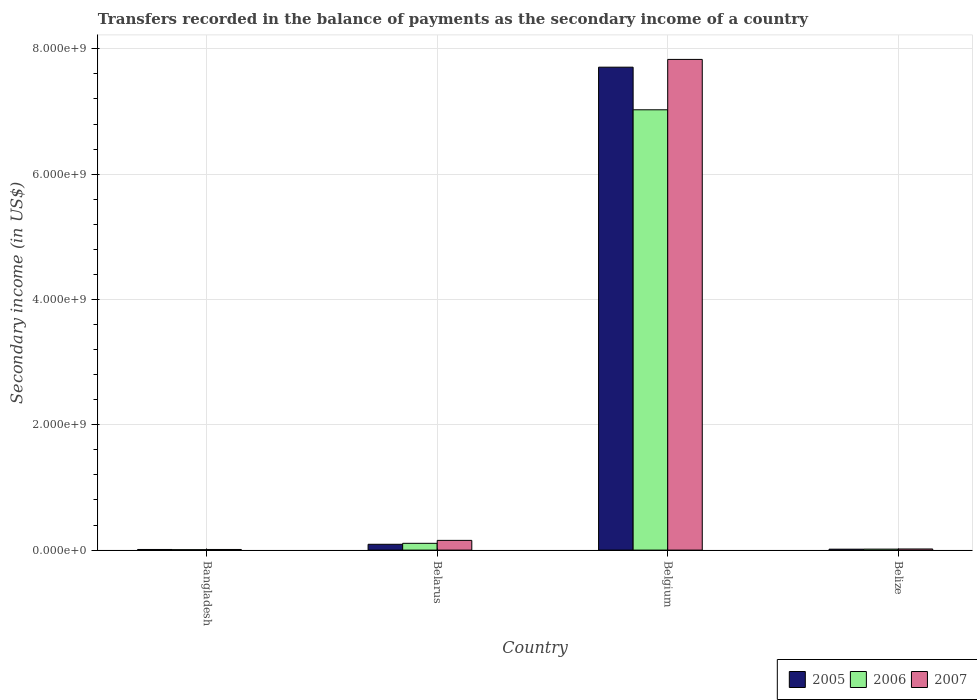How many different coloured bars are there?
Provide a succinct answer. 3. Are the number of bars on each tick of the X-axis equal?
Offer a very short reply. Yes. How many bars are there on the 4th tick from the left?
Ensure brevity in your answer.  3. What is the label of the 3rd group of bars from the left?
Ensure brevity in your answer.  Belgium. In how many cases, is the number of bars for a given country not equal to the number of legend labels?
Provide a short and direct response. 0. What is the secondary income of in 2005 in Bangladesh?
Your answer should be very brief. 9.91e+06. Across all countries, what is the maximum secondary income of in 2005?
Provide a short and direct response. 7.71e+09. Across all countries, what is the minimum secondary income of in 2007?
Ensure brevity in your answer.  1.01e+07. In which country was the secondary income of in 2006 minimum?
Your answer should be very brief. Bangladesh. What is the total secondary income of in 2007 in the graph?
Make the answer very short. 8.01e+09. What is the difference between the secondary income of in 2005 in Bangladesh and that in Belize?
Offer a very short reply. -4.86e+06. What is the difference between the secondary income of in 2006 in Belize and the secondary income of in 2007 in Belarus?
Give a very brief answer. -1.39e+08. What is the average secondary income of in 2007 per country?
Provide a short and direct response. 2.00e+09. What is the difference between the secondary income of of/in 2007 and secondary income of of/in 2005 in Belize?
Keep it short and to the point. 3.23e+06. What is the ratio of the secondary income of in 2005 in Belarus to that in Belgium?
Offer a very short reply. 0.01. Is the secondary income of in 2005 in Bangladesh less than that in Belarus?
Offer a terse response. Yes. Is the difference between the secondary income of in 2007 in Belarus and Belgium greater than the difference between the secondary income of in 2005 in Belarus and Belgium?
Your answer should be compact. No. What is the difference between the highest and the second highest secondary income of in 2007?
Your response must be concise. 1.37e+08. What is the difference between the highest and the lowest secondary income of in 2006?
Provide a short and direct response. 7.02e+09. In how many countries, is the secondary income of in 2005 greater than the average secondary income of in 2005 taken over all countries?
Make the answer very short. 1. Is the sum of the secondary income of in 2007 in Belgium and Belize greater than the maximum secondary income of in 2006 across all countries?
Offer a very short reply. Yes. How many bars are there?
Give a very brief answer. 12. Are all the bars in the graph horizontal?
Offer a very short reply. No. How many countries are there in the graph?
Provide a short and direct response. 4. What is the difference between two consecutive major ticks on the Y-axis?
Make the answer very short. 2.00e+09. Does the graph contain any zero values?
Provide a succinct answer. No. Where does the legend appear in the graph?
Provide a short and direct response. Bottom right. How are the legend labels stacked?
Provide a succinct answer. Horizontal. What is the title of the graph?
Your answer should be compact. Transfers recorded in the balance of payments as the secondary income of a country. What is the label or title of the Y-axis?
Give a very brief answer. Secondary income (in US$). What is the Secondary income (in US$) of 2005 in Bangladesh?
Provide a short and direct response. 9.91e+06. What is the Secondary income (in US$) in 2006 in Bangladesh?
Your answer should be compact. 6.82e+06. What is the Secondary income (in US$) of 2007 in Bangladesh?
Your answer should be very brief. 1.01e+07. What is the Secondary income (in US$) in 2005 in Belarus?
Offer a very short reply. 9.27e+07. What is the Secondary income (in US$) of 2006 in Belarus?
Keep it short and to the point. 1.08e+08. What is the Secondary income (in US$) in 2007 in Belarus?
Give a very brief answer. 1.55e+08. What is the Secondary income (in US$) in 2005 in Belgium?
Make the answer very short. 7.71e+09. What is the Secondary income (in US$) of 2006 in Belgium?
Offer a very short reply. 7.03e+09. What is the Secondary income (in US$) in 2007 in Belgium?
Ensure brevity in your answer.  7.83e+09. What is the Secondary income (in US$) of 2005 in Belize?
Provide a succinct answer. 1.48e+07. What is the Secondary income (in US$) in 2006 in Belize?
Your answer should be compact. 1.58e+07. What is the Secondary income (in US$) of 2007 in Belize?
Ensure brevity in your answer.  1.80e+07. Across all countries, what is the maximum Secondary income (in US$) in 2005?
Your answer should be very brief. 7.71e+09. Across all countries, what is the maximum Secondary income (in US$) in 2006?
Provide a succinct answer. 7.03e+09. Across all countries, what is the maximum Secondary income (in US$) in 2007?
Offer a very short reply. 7.83e+09. Across all countries, what is the minimum Secondary income (in US$) in 2005?
Offer a very short reply. 9.91e+06. Across all countries, what is the minimum Secondary income (in US$) in 2006?
Make the answer very short. 6.82e+06. Across all countries, what is the minimum Secondary income (in US$) of 2007?
Keep it short and to the point. 1.01e+07. What is the total Secondary income (in US$) of 2005 in the graph?
Your answer should be compact. 7.82e+09. What is the total Secondary income (in US$) in 2006 in the graph?
Give a very brief answer. 7.16e+09. What is the total Secondary income (in US$) of 2007 in the graph?
Keep it short and to the point. 8.01e+09. What is the difference between the Secondary income (in US$) of 2005 in Bangladesh and that in Belarus?
Keep it short and to the point. -8.28e+07. What is the difference between the Secondary income (in US$) of 2006 in Bangladesh and that in Belarus?
Make the answer very short. -1.01e+08. What is the difference between the Secondary income (in US$) in 2007 in Bangladesh and that in Belarus?
Provide a short and direct response. -1.45e+08. What is the difference between the Secondary income (in US$) in 2005 in Bangladesh and that in Belgium?
Provide a short and direct response. -7.70e+09. What is the difference between the Secondary income (in US$) in 2006 in Bangladesh and that in Belgium?
Your response must be concise. -7.02e+09. What is the difference between the Secondary income (in US$) of 2007 in Bangladesh and that in Belgium?
Provide a short and direct response. -7.82e+09. What is the difference between the Secondary income (in US$) in 2005 in Bangladesh and that in Belize?
Offer a terse response. -4.86e+06. What is the difference between the Secondary income (in US$) in 2006 in Bangladesh and that in Belize?
Your answer should be compact. -8.94e+06. What is the difference between the Secondary income (in US$) of 2007 in Bangladesh and that in Belize?
Keep it short and to the point. -7.92e+06. What is the difference between the Secondary income (in US$) of 2005 in Belarus and that in Belgium?
Your answer should be very brief. -7.61e+09. What is the difference between the Secondary income (in US$) of 2006 in Belarus and that in Belgium?
Ensure brevity in your answer.  -6.92e+09. What is the difference between the Secondary income (in US$) in 2007 in Belarus and that in Belgium?
Give a very brief answer. -7.68e+09. What is the difference between the Secondary income (in US$) in 2005 in Belarus and that in Belize?
Keep it short and to the point. 7.79e+07. What is the difference between the Secondary income (in US$) in 2006 in Belarus and that in Belize?
Make the answer very short. 9.23e+07. What is the difference between the Secondary income (in US$) in 2007 in Belarus and that in Belize?
Give a very brief answer. 1.37e+08. What is the difference between the Secondary income (in US$) in 2005 in Belgium and that in Belize?
Make the answer very short. 7.69e+09. What is the difference between the Secondary income (in US$) in 2006 in Belgium and that in Belize?
Offer a terse response. 7.01e+09. What is the difference between the Secondary income (in US$) in 2007 in Belgium and that in Belize?
Give a very brief answer. 7.81e+09. What is the difference between the Secondary income (in US$) in 2005 in Bangladesh and the Secondary income (in US$) in 2006 in Belarus?
Keep it short and to the point. -9.82e+07. What is the difference between the Secondary income (in US$) in 2005 in Bangladesh and the Secondary income (in US$) in 2007 in Belarus?
Your answer should be very brief. -1.45e+08. What is the difference between the Secondary income (in US$) in 2006 in Bangladesh and the Secondary income (in US$) in 2007 in Belarus?
Keep it short and to the point. -1.48e+08. What is the difference between the Secondary income (in US$) in 2005 in Bangladesh and the Secondary income (in US$) in 2006 in Belgium?
Make the answer very short. -7.02e+09. What is the difference between the Secondary income (in US$) in 2005 in Bangladesh and the Secondary income (in US$) in 2007 in Belgium?
Ensure brevity in your answer.  -7.82e+09. What is the difference between the Secondary income (in US$) of 2006 in Bangladesh and the Secondary income (in US$) of 2007 in Belgium?
Offer a terse response. -7.82e+09. What is the difference between the Secondary income (in US$) of 2005 in Bangladesh and the Secondary income (in US$) of 2006 in Belize?
Provide a short and direct response. -5.84e+06. What is the difference between the Secondary income (in US$) of 2005 in Bangladesh and the Secondary income (in US$) of 2007 in Belize?
Ensure brevity in your answer.  -8.09e+06. What is the difference between the Secondary income (in US$) in 2006 in Bangladesh and the Secondary income (in US$) in 2007 in Belize?
Offer a very short reply. -1.12e+07. What is the difference between the Secondary income (in US$) in 2005 in Belarus and the Secondary income (in US$) in 2006 in Belgium?
Ensure brevity in your answer.  -6.93e+09. What is the difference between the Secondary income (in US$) in 2005 in Belarus and the Secondary income (in US$) in 2007 in Belgium?
Make the answer very short. -7.74e+09. What is the difference between the Secondary income (in US$) of 2006 in Belarus and the Secondary income (in US$) of 2007 in Belgium?
Make the answer very short. -7.72e+09. What is the difference between the Secondary income (in US$) of 2005 in Belarus and the Secondary income (in US$) of 2006 in Belize?
Offer a very short reply. 7.69e+07. What is the difference between the Secondary income (in US$) of 2005 in Belarus and the Secondary income (in US$) of 2007 in Belize?
Your answer should be compact. 7.47e+07. What is the difference between the Secondary income (in US$) of 2006 in Belarus and the Secondary income (in US$) of 2007 in Belize?
Ensure brevity in your answer.  9.01e+07. What is the difference between the Secondary income (in US$) of 2005 in Belgium and the Secondary income (in US$) of 2006 in Belize?
Offer a very short reply. 7.69e+09. What is the difference between the Secondary income (in US$) of 2005 in Belgium and the Secondary income (in US$) of 2007 in Belize?
Ensure brevity in your answer.  7.69e+09. What is the difference between the Secondary income (in US$) of 2006 in Belgium and the Secondary income (in US$) of 2007 in Belize?
Provide a succinct answer. 7.01e+09. What is the average Secondary income (in US$) in 2005 per country?
Keep it short and to the point. 1.96e+09. What is the average Secondary income (in US$) in 2006 per country?
Offer a terse response. 1.79e+09. What is the average Secondary income (in US$) in 2007 per country?
Provide a short and direct response. 2.00e+09. What is the difference between the Secondary income (in US$) in 2005 and Secondary income (in US$) in 2006 in Bangladesh?
Your response must be concise. 3.09e+06. What is the difference between the Secondary income (in US$) of 2005 and Secondary income (in US$) of 2007 in Bangladesh?
Your answer should be compact. -1.71e+05. What is the difference between the Secondary income (in US$) of 2006 and Secondary income (in US$) of 2007 in Bangladesh?
Provide a short and direct response. -3.26e+06. What is the difference between the Secondary income (in US$) of 2005 and Secondary income (in US$) of 2006 in Belarus?
Your answer should be compact. -1.54e+07. What is the difference between the Secondary income (in US$) of 2005 and Secondary income (in US$) of 2007 in Belarus?
Provide a succinct answer. -6.23e+07. What is the difference between the Secondary income (in US$) in 2006 and Secondary income (in US$) in 2007 in Belarus?
Keep it short and to the point. -4.69e+07. What is the difference between the Secondary income (in US$) of 2005 and Secondary income (in US$) of 2006 in Belgium?
Keep it short and to the point. 6.80e+08. What is the difference between the Secondary income (in US$) of 2005 and Secondary income (in US$) of 2007 in Belgium?
Your response must be concise. -1.24e+08. What is the difference between the Secondary income (in US$) in 2006 and Secondary income (in US$) in 2007 in Belgium?
Provide a short and direct response. -8.04e+08. What is the difference between the Secondary income (in US$) in 2005 and Secondary income (in US$) in 2006 in Belize?
Keep it short and to the point. -9.82e+05. What is the difference between the Secondary income (in US$) in 2005 and Secondary income (in US$) in 2007 in Belize?
Make the answer very short. -3.23e+06. What is the difference between the Secondary income (in US$) in 2006 and Secondary income (in US$) in 2007 in Belize?
Your answer should be compact. -2.25e+06. What is the ratio of the Secondary income (in US$) in 2005 in Bangladesh to that in Belarus?
Make the answer very short. 0.11. What is the ratio of the Secondary income (in US$) in 2006 in Bangladesh to that in Belarus?
Provide a short and direct response. 0.06. What is the ratio of the Secondary income (in US$) of 2007 in Bangladesh to that in Belarus?
Provide a succinct answer. 0.07. What is the ratio of the Secondary income (in US$) in 2005 in Bangladesh to that in Belgium?
Ensure brevity in your answer.  0. What is the ratio of the Secondary income (in US$) in 2007 in Bangladesh to that in Belgium?
Your answer should be compact. 0. What is the ratio of the Secondary income (in US$) of 2005 in Bangladesh to that in Belize?
Your answer should be compact. 0.67. What is the ratio of the Secondary income (in US$) of 2006 in Bangladesh to that in Belize?
Your response must be concise. 0.43. What is the ratio of the Secondary income (in US$) of 2007 in Bangladesh to that in Belize?
Make the answer very short. 0.56. What is the ratio of the Secondary income (in US$) in 2005 in Belarus to that in Belgium?
Provide a short and direct response. 0.01. What is the ratio of the Secondary income (in US$) in 2006 in Belarus to that in Belgium?
Ensure brevity in your answer.  0.02. What is the ratio of the Secondary income (in US$) of 2007 in Belarus to that in Belgium?
Your answer should be compact. 0.02. What is the ratio of the Secondary income (in US$) in 2005 in Belarus to that in Belize?
Your answer should be compact. 6.28. What is the ratio of the Secondary income (in US$) of 2006 in Belarus to that in Belize?
Your response must be concise. 6.86. What is the ratio of the Secondary income (in US$) in 2007 in Belarus to that in Belize?
Give a very brief answer. 8.61. What is the ratio of the Secondary income (in US$) in 2005 in Belgium to that in Belize?
Keep it short and to the point. 521.84. What is the ratio of the Secondary income (in US$) in 2006 in Belgium to that in Belize?
Your response must be concise. 446.15. What is the ratio of the Secondary income (in US$) in 2007 in Belgium to that in Belize?
Your answer should be compact. 435.15. What is the difference between the highest and the second highest Secondary income (in US$) in 2005?
Keep it short and to the point. 7.61e+09. What is the difference between the highest and the second highest Secondary income (in US$) in 2006?
Your answer should be very brief. 6.92e+09. What is the difference between the highest and the second highest Secondary income (in US$) of 2007?
Your response must be concise. 7.68e+09. What is the difference between the highest and the lowest Secondary income (in US$) in 2005?
Your answer should be compact. 7.70e+09. What is the difference between the highest and the lowest Secondary income (in US$) of 2006?
Offer a terse response. 7.02e+09. What is the difference between the highest and the lowest Secondary income (in US$) of 2007?
Offer a terse response. 7.82e+09. 